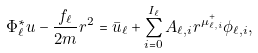Convert formula to latex. <formula><loc_0><loc_0><loc_500><loc_500>\Phi _ { \ell } ^ { * } u - \frac { f _ { \ell } } { 2 m } r ^ { 2 } = \bar { u } _ { \ell } + \sum _ { i = 0 } ^ { I _ { \ell } } A _ { \ell , i } r ^ { \mu _ { \ell , i } ^ { + } } \phi _ { \ell , i } ,</formula> 